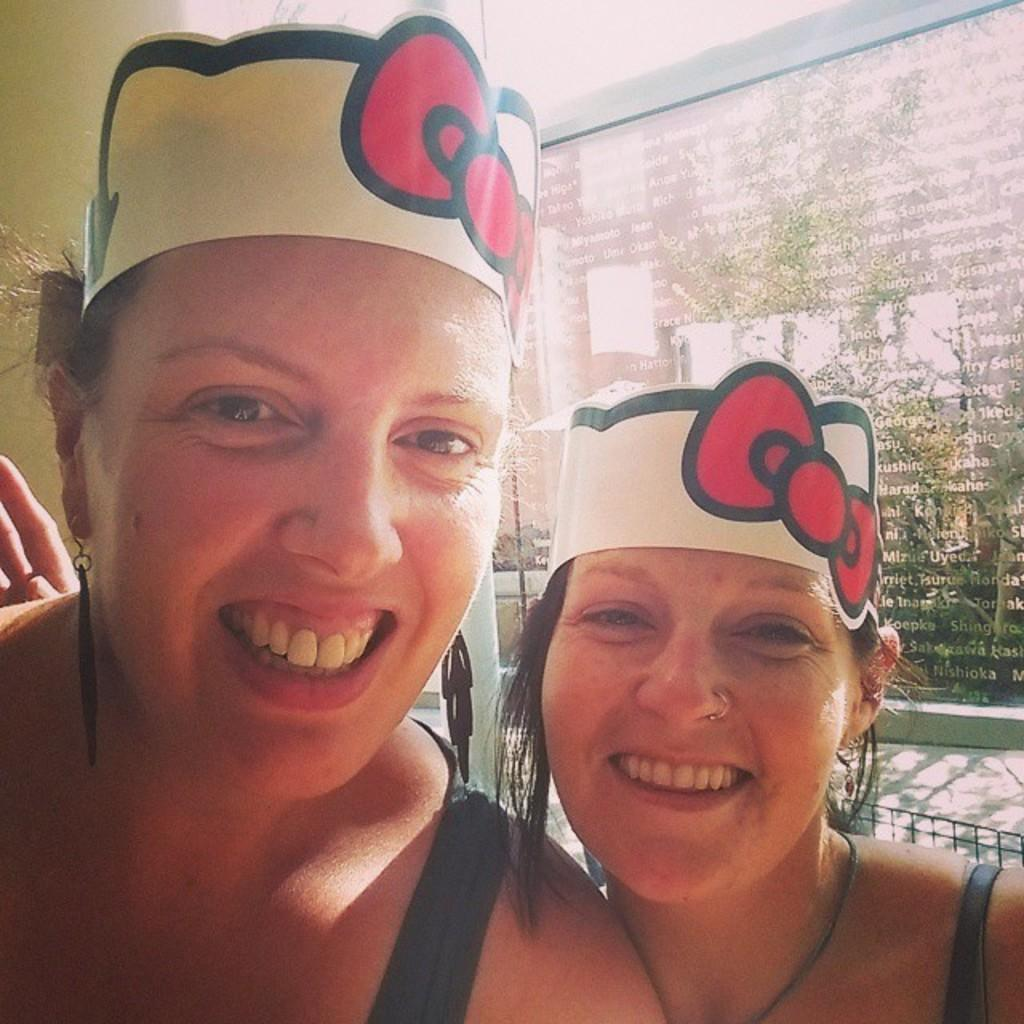How many women are in the image? There are two women in the image. What are the women wearing on their heads? The women are wearing hats. What can be seen in the background of the image? There is a glass window with text on it, a metal grill, plants, and a wall in the background. What type of toys can be seen on the canvas in the image? There is no canvas or toys present in the image. 